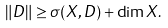<formula> <loc_0><loc_0><loc_500><loc_500>\| D \| \geq \sigma ( X , D ) + \dim X .</formula> 